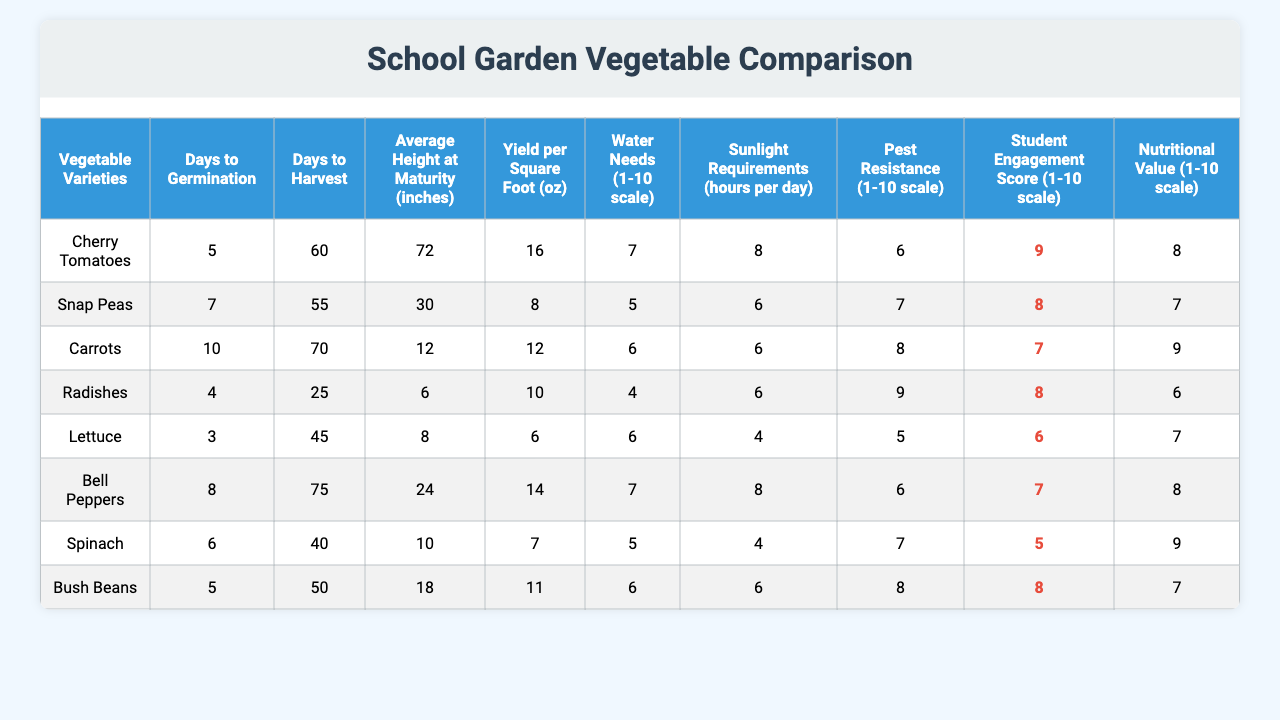What is the yield per square foot of Cherry Tomatoes? The yield per square foot value for Cherry Tomatoes can be retrieved directly from the table, where it is listed as 16 oz.
Answer: 16 oz Which vegetable takes the least time to germinate? By comparing the "Days to Germination" column, Radishes have the lowest value at 4 days.
Answer: Radishes What is the average height at maturity for all vegetables listed? To find the average height, sum all the height values (72 + 30 + 12 + 6 + 8 + 24 + 10 + 18 = 180) and divide by the number of varieties (8). The average height is 180/8 = 22.5 inches.
Answer: 22.5 inches How many vegetables mature in less than 50 days? Looking at the "Days to Harvest" column, the vegetables that mature in less than 50 days are Snap Peas (55 days), Radishes (25 days), and Spinach (40 days). That totals to 3.
Answer: 3 Is there a vegetable that has both high yield and low water needs? By examining the "Yield per Square Foot" and "Water Needs" columns, Bell Peppers have a good yield of 14 oz and a water need rating of 7, which isn't low. However, Bush Beans yield 11 oz and have a water need of 6. They fulfill this condition.
Answer: Yes What is the difference in yield per square foot between Cherry Tomatoes and Carrots? The yield for Cherry Tomatoes is 16 oz, and for Carrots, it is 12 oz. The difference is 16 - 12 = 4 oz.
Answer: 4 oz Which vegetable has the highest student engagement score? The "Student Engagement Score" column shows that Cherry Tomatoes have the highest score of 9.
Answer: 9 Which vegetable has the lowest nutritional value? In the "Nutritional Value" column, Lettuce has the lowest score at 6.
Answer: Lettuce How does the average yield compare between vegetables that require 6 hours of sunlight versus those that require 8 hours? First, calculate the average yield for 6 hours of sunlight: Snap Peas (8 oz), Carrots (12 oz), Radishes (10 oz), Spinach (7 oz), Bush Beans (11 oz). Their total is 48 oz. The average is 48/5 = 9.6 oz. For 8 hours, the yield is Cherry Tomatoes (16 oz) and Bell Peppers (14 oz). The total is 30 oz, and the average is 30/2 = 15 oz. The difference is 15 - 9.6 = 5.4 oz.
Answer: 5.4 oz How many vegetable varieties have a pest resistance score of 8 or higher? By reviewing the "Pest Resistance" column, the vegetables with scores of 8 or higher are Snap Peas, Carrots, Radishes, Bush Beans, and Spinach. That totals to 5 varieties.
Answer: 5 